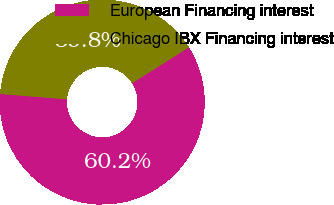Convert chart. <chart><loc_0><loc_0><loc_500><loc_500><pie_chart><fcel>European Financing interest<fcel>Chicago IBX Financing interest<nl><fcel>60.23%<fcel>39.77%<nl></chart> 